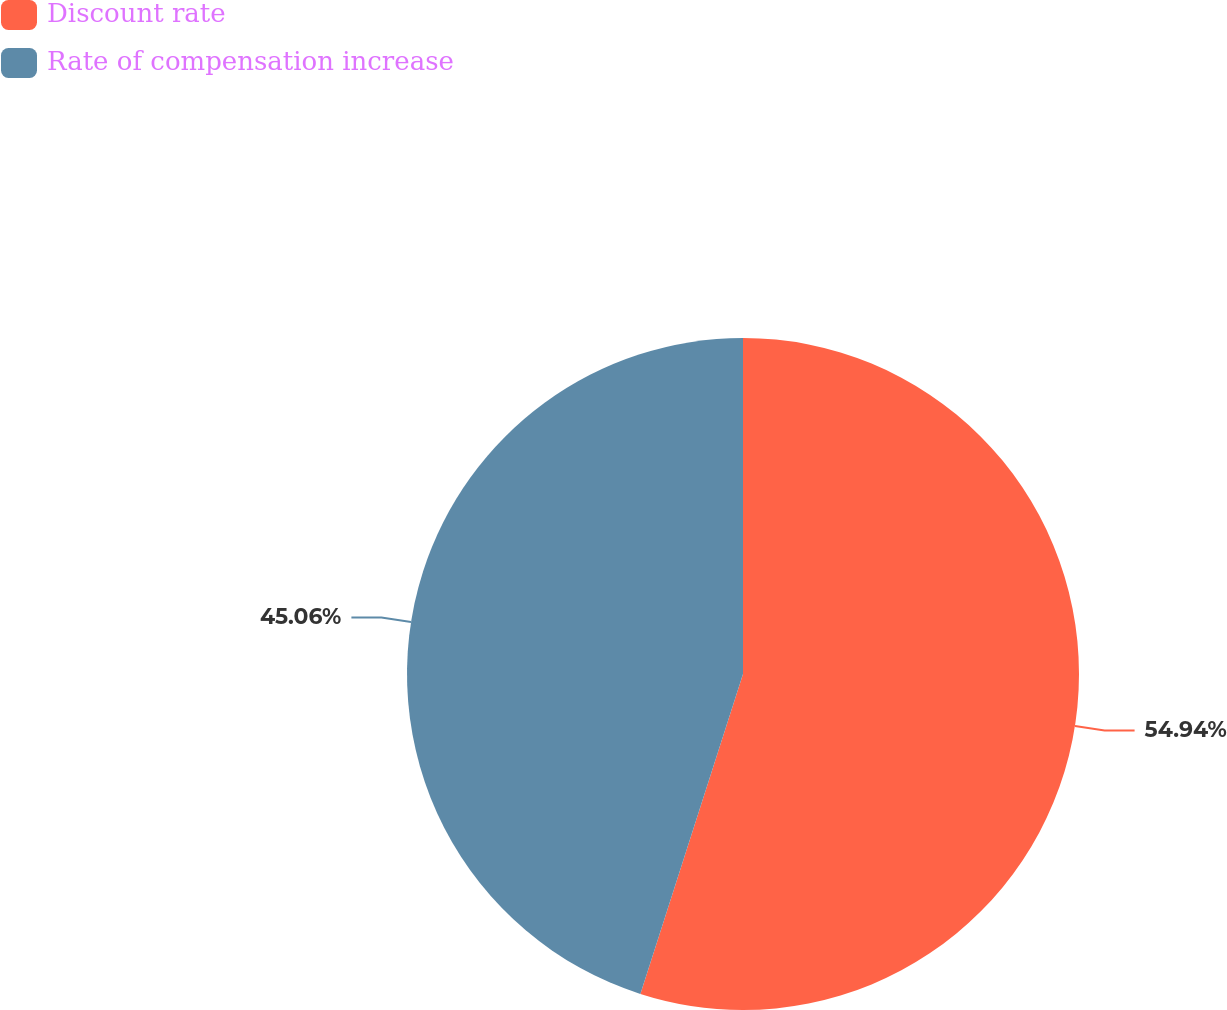Convert chart to OTSL. <chart><loc_0><loc_0><loc_500><loc_500><pie_chart><fcel>Discount rate<fcel>Rate of compensation increase<nl><fcel>54.94%<fcel>45.06%<nl></chart> 